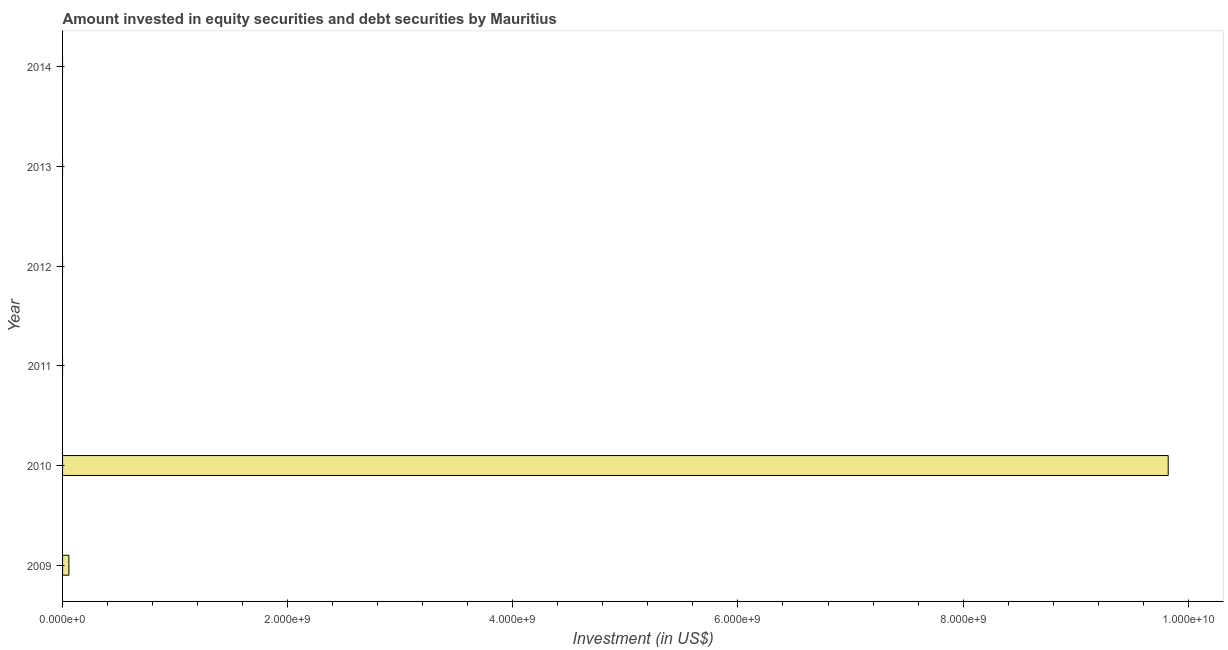Does the graph contain any zero values?
Your answer should be compact. Yes. What is the title of the graph?
Keep it short and to the point. Amount invested in equity securities and debt securities by Mauritius. What is the label or title of the X-axis?
Provide a succinct answer. Investment (in US$). What is the label or title of the Y-axis?
Offer a terse response. Year. What is the portfolio investment in 2009?
Provide a short and direct response. 5.63e+07. Across all years, what is the maximum portfolio investment?
Your answer should be compact. 9.82e+09. Across all years, what is the minimum portfolio investment?
Your answer should be very brief. 0. What is the sum of the portfolio investment?
Provide a short and direct response. 9.88e+09. What is the average portfolio investment per year?
Offer a very short reply. 1.65e+09. What is the median portfolio investment?
Provide a succinct answer. 0. Is the difference between the portfolio investment in 2009 and 2010 greater than the difference between any two years?
Ensure brevity in your answer.  No. What is the difference between the highest and the lowest portfolio investment?
Your answer should be very brief. 9.82e+09. In how many years, is the portfolio investment greater than the average portfolio investment taken over all years?
Keep it short and to the point. 1. How many years are there in the graph?
Provide a succinct answer. 6. What is the difference between two consecutive major ticks on the X-axis?
Ensure brevity in your answer.  2.00e+09. Are the values on the major ticks of X-axis written in scientific E-notation?
Keep it short and to the point. Yes. What is the Investment (in US$) in 2009?
Your answer should be very brief. 5.63e+07. What is the Investment (in US$) in 2010?
Offer a very short reply. 9.82e+09. What is the Investment (in US$) in 2012?
Make the answer very short. 0. What is the difference between the Investment (in US$) in 2009 and 2010?
Give a very brief answer. -9.77e+09. What is the ratio of the Investment (in US$) in 2009 to that in 2010?
Ensure brevity in your answer.  0.01. 